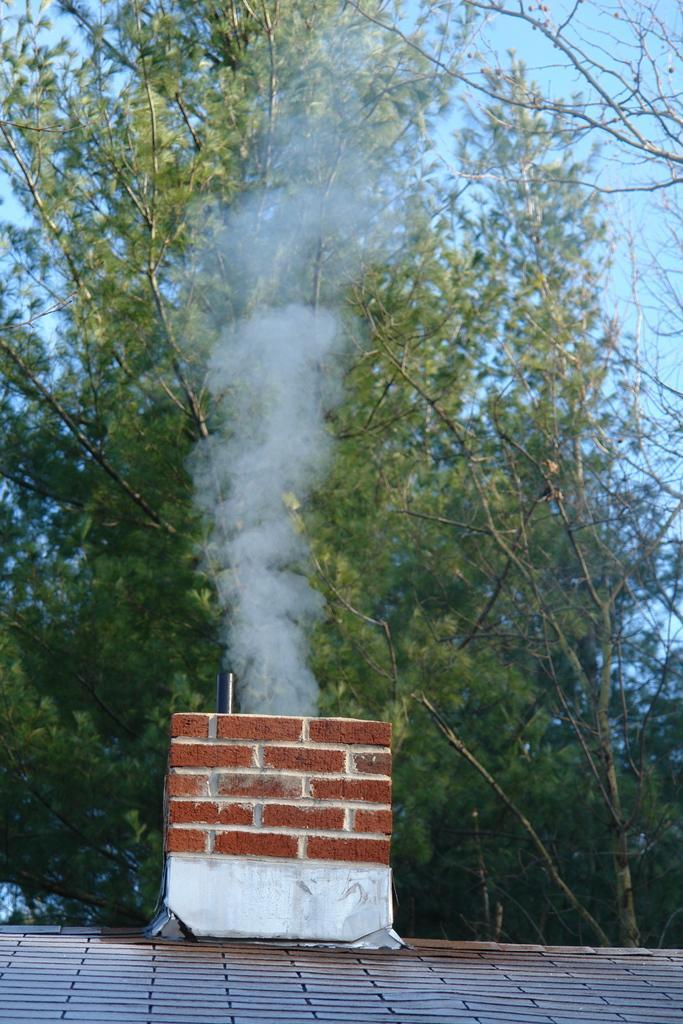How would you summarize this image in a sentence or two? In this image, I can see a rooftop chimney and smoke. In the background, there are trees and the sky. 